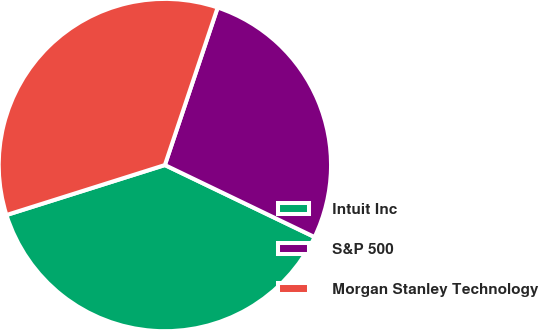Convert chart. <chart><loc_0><loc_0><loc_500><loc_500><pie_chart><fcel>Intuit Inc<fcel>S&P 500<fcel>Morgan Stanley Technology<nl><fcel>38.0%<fcel>26.99%<fcel>35.01%<nl></chart> 